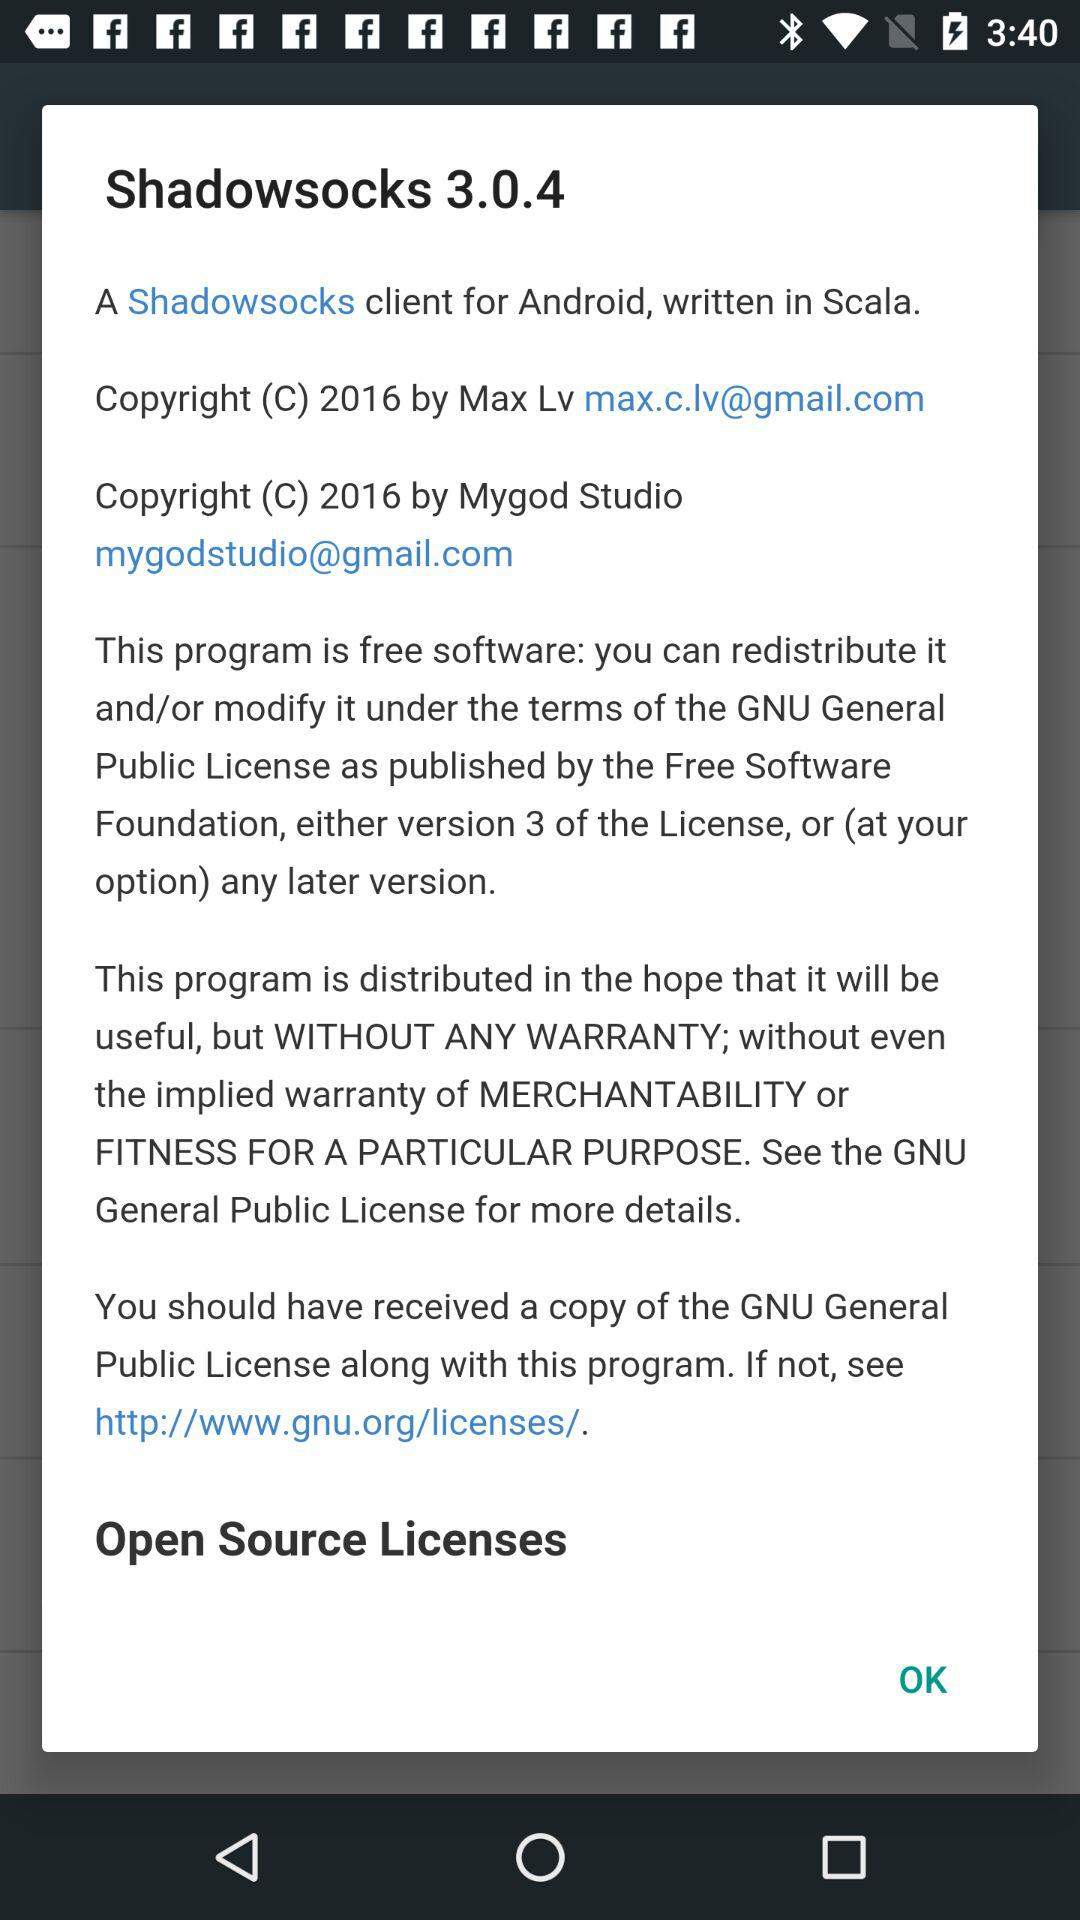What is the version of the Shadowsocks? The version of the Shadowsocks is 3.0.4. 